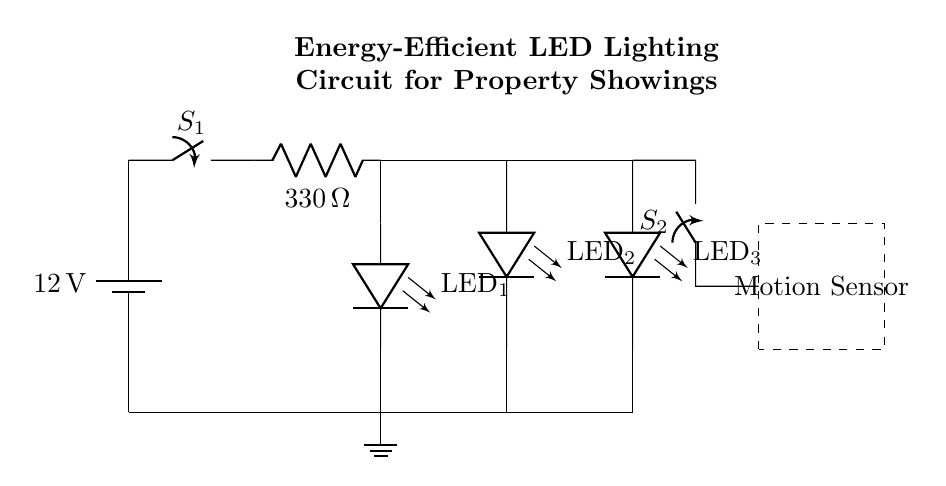What is the voltage source used in this circuit? The circuit uses a twelve-volt battery as the power source, indicated at the left side of the diagram where it states "12 V".
Answer: 12 V What component limits the current in the circuit? The resistor labeled "R1" is responsible for limiting the current, showing a value of 330 ohms, which helps protect the LEDs from excessive current.
Answer: 330 ohms How many LEDs are connected in this circuit? There are three LEDs shown in the circuit diagram, indicated by "LED1", "LED2", and "LED3", all connected in parallel, allowing each to receive voltage separately.
Answer: Three What is the function of the motion sensor in this circuit? The motion sensor, depicted in the dashed rectangle, detects movement and can control the on/off state of the lighting circuit, enabling automatic illumination when someone is present.
Answer: To detect motion Which switch controls the main power to the circuit? The switch labeled "S1" at the top of the circuit diagram serves as the main power switch, allowing the entire circuit's lighting to be turned on or off.
Answer: S1 How are the LEDs connected in the circuit? The LEDs are connected in parallel; this means that each LED has its own path to the same voltage source, allowing them to operate independently of each other.
Answer: In parallel What happens to the circuit when the motion sensor is activated? When the motion sensor is activated, it closes switch S2, allowing current to flow through and turning on the LEDs, providing illumination in response to detected motion.
Answer: LEDs turn on 